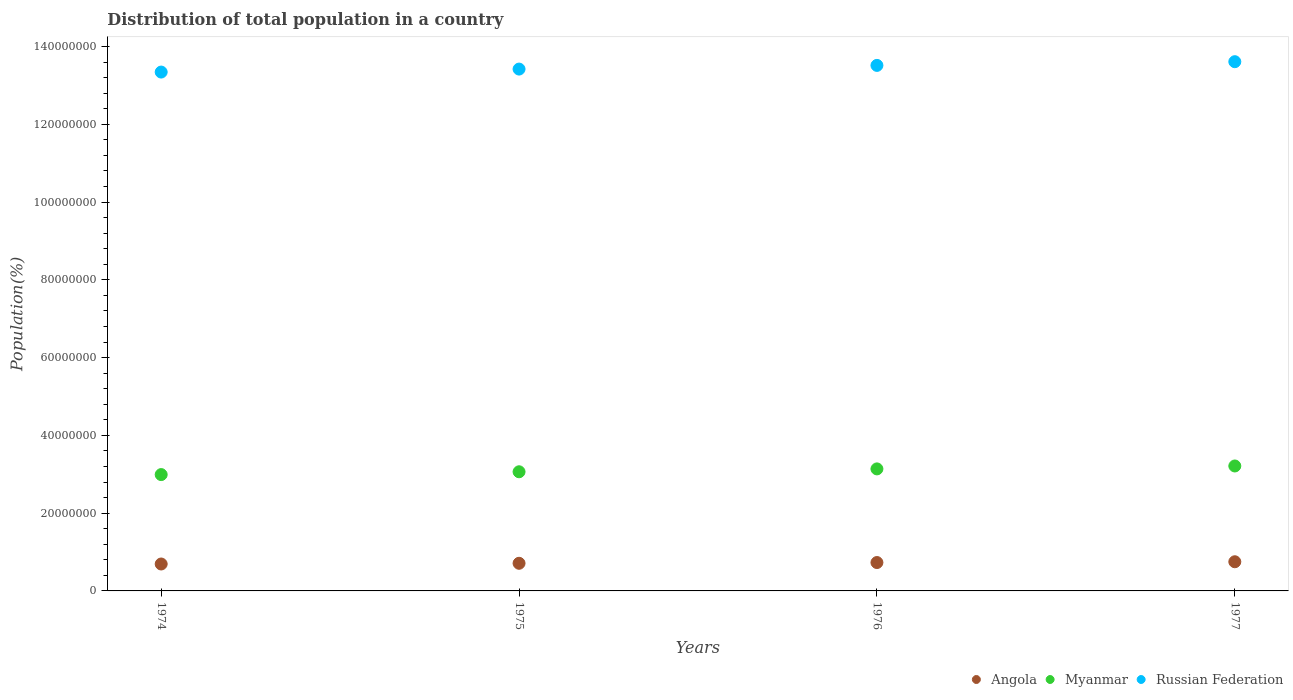How many different coloured dotlines are there?
Ensure brevity in your answer.  3. What is the population of in Myanmar in 1974?
Keep it short and to the point. 2.99e+07. Across all years, what is the maximum population of in Myanmar?
Your answer should be very brief. 3.21e+07. Across all years, what is the minimum population of in Myanmar?
Provide a succinct answer. 2.99e+07. In which year was the population of in Russian Federation maximum?
Keep it short and to the point. 1977. In which year was the population of in Angola minimum?
Keep it short and to the point. 1974. What is the total population of in Angola in the graph?
Provide a succinct answer. 2.88e+07. What is the difference between the population of in Angola in 1975 and that in 1977?
Ensure brevity in your answer.  -3.94e+05. What is the difference between the population of in Myanmar in 1977 and the population of in Angola in 1974?
Offer a very short reply. 2.52e+07. What is the average population of in Russian Federation per year?
Provide a short and direct response. 1.35e+08. In the year 1976, what is the difference between the population of in Myanmar and population of in Angola?
Offer a very short reply. 2.41e+07. In how many years, is the population of in Angola greater than 28000000 %?
Your answer should be compact. 0. What is the ratio of the population of in Russian Federation in 1975 to that in 1977?
Offer a terse response. 0.99. Is the population of in Myanmar in 1974 less than that in 1977?
Your answer should be very brief. Yes. What is the difference between the highest and the second highest population of in Angola?
Ensure brevity in your answer.  2.02e+05. What is the difference between the highest and the lowest population of in Myanmar?
Make the answer very short. 2.21e+06. In how many years, is the population of in Myanmar greater than the average population of in Myanmar taken over all years?
Give a very brief answer. 2. Is the sum of the population of in Angola in 1974 and 1975 greater than the maximum population of in Myanmar across all years?
Give a very brief answer. No. Is it the case that in every year, the sum of the population of in Myanmar and population of in Angola  is greater than the population of in Russian Federation?
Make the answer very short. No. Does the population of in Myanmar monotonically increase over the years?
Offer a terse response. Yes. Is the population of in Myanmar strictly less than the population of in Angola over the years?
Offer a very short reply. No. What is the difference between two consecutive major ticks on the Y-axis?
Provide a succinct answer. 2.00e+07. Does the graph contain any zero values?
Offer a very short reply. No. What is the title of the graph?
Ensure brevity in your answer.  Distribution of total population in a country. What is the label or title of the X-axis?
Your response must be concise. Years. What is the label or title of the Y-axis?
Keep it short and to the point. Population(%). What is the Population(%) of Angola in 1974?
Offer a very short reply. 6.92e+06. What is the Population(%) in Myanmar in 1974?
Your answer should be compact. 2.99e+07. What is the Population(%) in Russian Federation in 1974?
Give a very brief answer. 1.33e+08. What is the Population(%) of Angola in 1975?
Offer a very short reply. 7.11e+06. What is the Population(%) in Myanmar in 1975?
Ensure brevity in your answer.  3.06e+07. What is the Population(%) of Russian Federation in 1975?
Your answer should be compact. 1.34e+08. What is the Population(%) of Angola in 1976?
Your answer should be compact. 7.30e+06. What is the Population(%) in Myanmar in 1976?
Your answer should be compact. 3.14e+07. What is the Population(%) in Russian Federation in 1976?
Provide a succinct answer. 1.35e+08. What is the Population(%) of Angola in 1977?
Give a very brief answer. 7.50e+06. What is the Population(%) of Myanmar in 1977?
Keep it short and to the point. 3.21e+07. What is the Population(%) of Russian Federation in 1977?
Your response must be concise. 1.36e+08. Across all years, what is the maximum Population(%) in Angola?
Ensure brevity in your answer.  7.50e+06. Across all years, what is the maximum Population(%) in Myanmar?
Make the answer very short. 3.21e+07. Across all years, what is the maximum Population(%) of Russian Federation?
Provide a succinct answer. 1.36e+08. Across all years, what is the minimum Population(%) in Angola?
Your answer should be compact. 6.92e+06. Across all years, what is the minimum Population(%) in Myanmar?
Offer a very short reply. 2.99e+07. Across all years, what is the minimum Population(%) of Russian Federation?
Ensure brevity in your answer.  1.33e+08. What is the total Population(%) in Angola in the graph?
Provide a short and direct response. 2.88e+07. What is the total Population(%) in Myanmar in the graph?
Offer a very short reply. 1.24e+08. What is the total Population(%) of Russian Federation in the graph?
Provide a short and direct response. 5.39e+08. What is the difference between the Population(%) of Angola in 1974 and that in 1975?
Keep it short and to the point. -1.84e+05. What is the difference between the Population(%) in Myanmar in 1974 and that in 1975?
Your response must be concise. -7.24e+05. What is the difference between the Population(%) in Russian Federation in 1974 and that in 1975?
Your response must be concise. -7.68e+05. What is the difference between the Population(%) in Angola in 1974 and that in 1976?
Provide a short and direct response. -3.76e+05. What is the difference between the Population(%) in Myanmar in 1974 and that in 1976?
Provide a succinct answer. -1.46e+06. What is the difference between the Population(%) of Russian Federation in 1974 and that in 1976?
Offer a terse response. -1.72e+06. What is the difference between the Population(%) of Angola in 1974 and that in 1977?
Offer a very short reply. -5.78e+05. What is the difference between the Population(%) of Myanmar in 1974 and that in 1977?
Provide a short and direct response. -2.21e+06. What is the difference between the Population(%) of Russian Federation in 1974 and that in 1977?
Your answer should be compact. -2.67e+06. What is the difference between the Population(%) in Angola in 1975 and that in 1976?
Your response must be concise. -1.92e+05. What is the difference between the Population(%) in Myanmar in 1975 and that in 1976?
Offer a very short reply. -7.39e+05. What is the difference between the Population(%) in Russian Federation in 1975 and that in 1976?
Your answer should be compact. -9.47e+05. What is the difference between the Population(%) in Angola in 1975 and that in 1977?
Provide a short and direct response. -3.94e+05. What is the difference between the Population(%) in Myanmar in 1975 and that in 1977?
Offer a terse response. -1.49e+06. What is the difference between the Population(%) of Russian Federation in 1975 and that in 1977?
Offer a terse response. -1.90e+06. What is the difference between the Population(%) in Angola in 1976 and that in 1977?
Keep it short and to the point. -2.02e+05. What is the difference between the Population(%) of Myanmar in 1976 and that in 1977?
Give a very brief answer. -7.51e+05. What is the difference between the Population(%) of Russian Federation in 1976 and that in 1977?
Offer a very short reply. -9.53e+05. What is the difference between the Population(%) in Angola in 1974 and the Population(%) in Myanmar in 1975?
Your answer should be compact. -2.37e+07. What is the difference between the Population(%) of Angola in 1974 and the Population(%) of Russian Federation in 1975?
Your answer should be very brief. -1.27e+08. What is the difference between the Population(%) in Myanmar in 1974 and the Population(%) in Russian Federation in 1975?
Ensure brevity in your answer.  -1.04e+08. What is the difference between the Population(%) of Angola in 1974 and the Population(%) of Myanmar in 1976?
Your response must be concise. -2.45e+07. What is the difference between the Population(%) in Angola in 1974 and the Population(%) in Russian Federation in 1976?
Offer a terse response. -1.28e+08. What is the difference between the Population(%) in Myanmar in 1974 and the Population(%) in Russian Federation in 1976?
Ensure brevity in your answer.  -1.05e+08. What is the difference between the Population(%) in Angola in 1974 and the Population(%) in Myanmar in 1977?
Provide a succinct answer. -2.52e+07. What is the difference between the Population(%) in Angola in 1974 and the Population(%) in Russian Federation in 1977?
Give a very brief answer. -1.29e+08. What is the difference between the Population(%) in Myanmar in 1974 and the Population(%) in Russian Federation in 1977?
Make the answer very short. -1.06e+08. What is the difference between the Population(%) in Angola in 1975 and the Population(%) in Myanmar in 1976?
Make the answer very short. -2.43e+07. What is the difference between the Population(%) in Angola in 1975 and the Population(%) in Russian Federation in 1976?
Offer a terse response. -1.28e+08. What is the difference between the Population(%) in Myanmar in 1975 and the Population(%) in Russian Federation in 1976?
Your answer should be very brief. -1.05e+08. What is the difference between the Population(%) of Angola in 1975 and the Population(%) of Myanmar in 1977?
Make the answer very short. -2.50e+07. What is the difference between the Population(%) of Angola in 1975 and the Population(%) of Russian Federation in 1977?
Your answer should be very brief. -1.29e+08. What is the difference between the Population(%) of Myanmar in 1975 and the Population(%) of Russian Federation in 1977?
Provide a succinct answer. -1.05e+08. What is the difference between the Population(%) in Angola in 1976 and the Population(%) in Myanmar in 1977?
Provide a succinct answer. -2.48e+07. What is the difference between the Population(%) of Angola in 1976 and the Population(%) of Russian Federation in 1977?
Your answer should be compact. -1.29e+08. What is the difference between the Population(%) of Myanmar in 1976 and the Population(%) of Russian Federation in 1977?
Give a very brief answer. -1.05e+08. What is the average Population(%) of Angola per year?
Keep it short and to the point. 7.21e+06. What is the average Population(%) in Myanmar per year?
Provide a succinct answer. 3.10e+07. What is the average Population(%) in Russian Federation per year?
Make the answer very short. 1.35e+08. In the year 1974, what is the difference between the Population(%) of Angola and Population(%) of Myanmar?
Your answer should be compact. -2.30e+07. In the year 1974, what is the difference between the Population(%) in Angola and Population(%) in Russian Federation?
Your answer should be compact. -1.27e+08. In the year 1974, what is the difference between the Population(%) in Myanmar and Population(%) in Russian Federation?
Offer a very short reply. -1.04e+08. In the year 1975, what is the difference between the Population(%) of Angola and Population(%) of Myanmar?
Provide a short and direct response. -2.35e+07. In the year 1975, what is the difference between the Population(%) of Angola and Population(%) of Russian Federation?
Your answer should be very brief. -1.27e+08. In the year 1975, what is the difference between the Population(%) of Myanmar and Population(%) of Russian Federation?
Make the answer very short. -1.04e+08. In the year 1976, what is the difference between the Population(%) of Angola and Population(%) of Myanmar?
Give a very brief answer. -2.41e+07. In the year 1976, what is the difference between the Population(%) of Angola and Population(%) of Russian Federation?
Make the answer very short. -1.28e+08. In the year 1976, what is the difference between the Population(%) in Myanmar and Population(%) in Russian Federation?
Offer a very short reply. -1.04e+08. In the year 1977, what is the difference between the Population(%) in Angola and Population(%) in Myanmar?
Your answer should be compact. -2.46e+07. In the year 1977, what is the difference between the Population(%) of Angola and Population(%) of Russian Federation?
Provide a succinct answer. -1.29e+08. In the year 1977, what is the difference between the Population(%) of Myanmar and Population(%) of Russian Federation?
Keep it short and to the point. -1.04e+08. What is the ratio of the Population(%) of Angola in 1974 to that in 1975?
Offer a very short reply. 0.97. What is the ratio of the Population(%) of Myanmar in 1974 to that in 1975?
Your answer should be very brief. 0.98. What is the ratio of the Population(%) of Russian Federation in 1974 to that in 1975?
Your answer should be very brief. 0.99. What is the ratio of the Population(%) in Angola in 1974 to that in 1976?
Offer a very short reply. 0.95. What is the ratio of the Population(%) in Myanmar in 1974 to that in 1976?
Make the answer very short. 0.95. What is the ratio of the Population(%) in Russian Federation in 1974 to that in 1976?
Keep it short and to the point. 0.99. What is the ratio of the Population(%) in Angola in 1974 to that in 1977?
Your answer should be very brief. 0.92. What is the ratio of the Population(%) of Myanmar in 1974 to that in 1977?
Your answer should be very brief. 0.93. What is the ratio of the Population(%) of Russian Federation in 1974 to that in 1977?
Give a very brief answer. 0.98. What is the ratio of the Population(%) of Angola in 1975 to that in 1976?
Keep it short and to the point. 0.97. What is the ratio of the Population(%) of Myanmar in 1975 to that in 1976?
Ensure brevity in your answer.  0.98. What is the ratio of the Population(%) of Russian Federation in 1975 to that in 1976?
Give a very brief answer. 0.99. What is the ratio of the Population(%) in Angola in 1975 to that in 1977?
Ensure brevity in your answer.  0.95. What is the ratio of the Population(%) in Myanmar in 1975 to that in 1977?
Keep it short and to the point. 0.95. What is the ratio of the Population(%) of Angola in 1976 to that in 1977?
Offer a very short reply. 0.97. What is the ratio of the Population(%) of Myanmar in 1976 to that in 1977?
Your response must be concise. 0.98. What is the ratio of the Population(%) of Russian Federation in 1976 to that in 1977?
Keep it short and to the point. 0.99. What is the difference between the highest and the second highest Population(%) of Angola?
Your answer should be compact. 2.02e+05. What is the difference between the highest and the second highest Population(%) of Myanmar?
Provide a short and direct response. 7.51e+05. What is the difference between the highest and the second highest Population(%) in Russian Federation?
Give a very brief answer. 9.53e+05. What is the difference between the highest and the lowest Population(%) of Angola?
Your answer should be compact. 5.78e+05. What is the difference between the highest and the lowest Population(%) in Myanmar?
Your response must be concise. 2.21e+06. What is the difference between the highest and the lowest Population(%) of Russian Federation?
Give a very brief answer. 2.67e+06. 